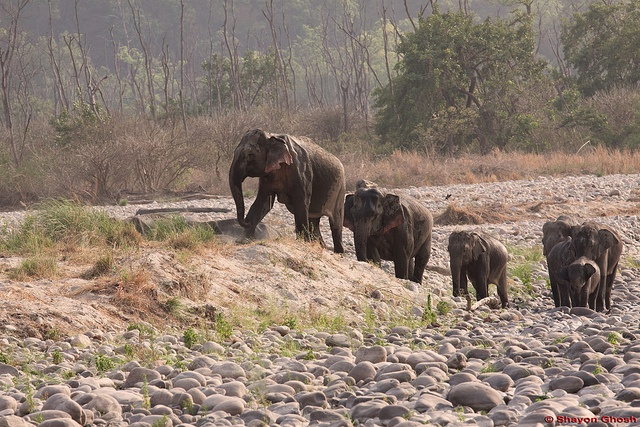Describe the objects in this image and their specific colors. I can see elephant in gray and black tones, elephant in gray, black, and darkgray tones, elephant in gray and black tones, elephant in gray and black tones, and elephant in gray and black tones in this image. 